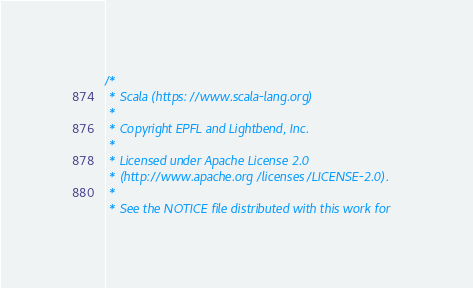<code> <loc_0><loc_0><loc_500><loc_500><_Scala_>/*
 * Scala (https://www.scala-lang.org)
 *
 * Copyright EPFL and Lightbend, Inc.
 *
 * Licensed under Apache License 2.0
 * (http://www.apache.org/licenses/LICENSE-2.0).
 *
 * See the NOTICE file distributed with this work for</code> 